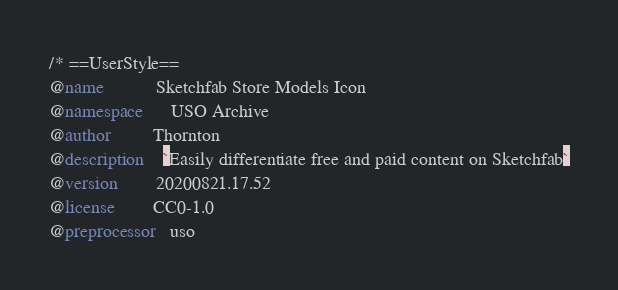Convert code to text. <code><loc_0><loc_0><loc_500><loc_500><_CSS_>/* ==UserStyle==
@name           Sketchfab Store Models Icon
@namespace      USO Archive
@author         Thornton
@description    `Easily differentiate free and paid content on Sketchfab`
@version        20200821.17.52
@license        CC0-1.0
@preprocessor   uso</code> 